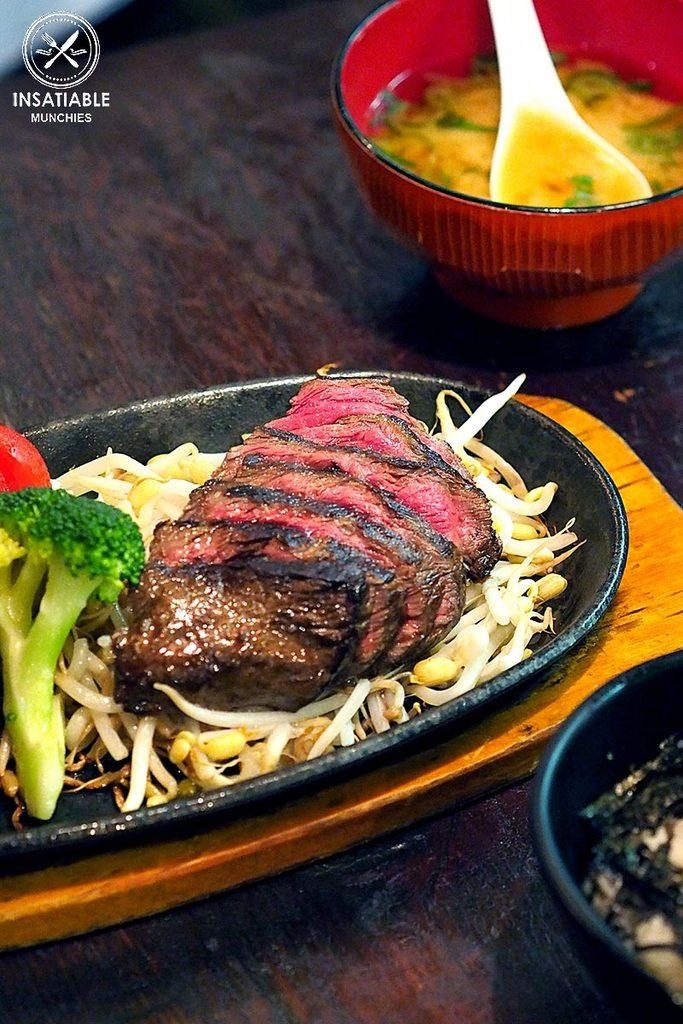What is the main piece of furniture in the image? There is a table in the image. What is on the table? There are food items on the table. How many bowls are on the table? There are two bowls on the table. What is in each bowl? Each bowl contains a spoon and a food item. What type of vegetable is being driven by the van in the image? There is no vegetable or van present in the image. 